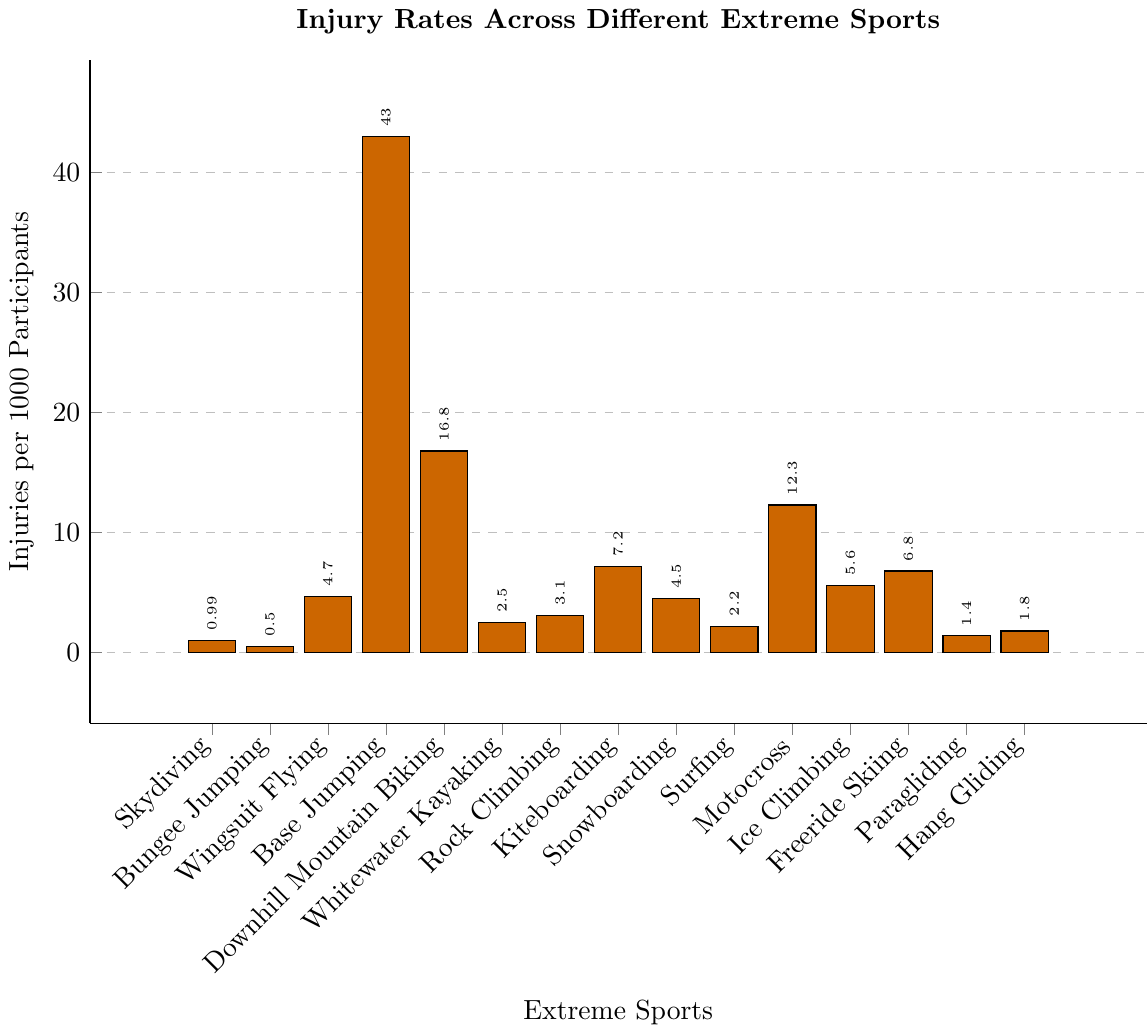Which sport has the highest injury rate? The sport with the highest injury rate can be identified by looking for the tallest bar in the bar chart. Base Jumping has the tallest bar.
Answer: Base Jumping Which two sports have the lowest injury rates? The two sports with the shortest bars represent the lowest injury rates. The shortest bars belong to Bungee Jumping and Skydiving.
Answer: Bungee Jumping and Skydiving What is the difference in injury rates between Motocross and Snowboarding? To find the difference, subtract the injury rate of Snowboarding (4.5) from the injury rate of Motocross (12.3). 12.3 - 4.5 = 7.8.
Answer: 7.8 Which sport has an injury rate closest to 5 injuries per 1000 participants? By examining the heights of the bars near the 5 mark on the y-axis, we see that Ice Climbing (5.6) is the closest.
Answer: Ice Climbing How do the injury rates of Hang Gliding and Paragliding compare? Compare the heights of the bars for Hang Gliding (1.8) and Paragliding (1.4). Hang Gliding has a slightly higher injury rate than Paragliding.
Answer: Hang Gliding has a higher rate What is the average injury rate across all listed extreme sports? Add all the injury rates and divide by the number of sports. Total injuries = 0.99+0.5+4.7+43+16.8+2.5+3.1+7.2+4.5+2.2+12.3+5.6+6.8+1.4+1.8 = 113.19. Number of sports = 15. Average = 113.19 / 15 = 7.55.
Answer: 7.55 By how much does the injury rate of Downhill Mountain Biking exceed that of Surfing? To find the excess, subtract the injury rate of Surfing (2.2) from Downhill Mountain Biking (16.8). 16.8 - 2.2 = 14.6.
Answer: 14.6 Which sports have an injury rate greater than 5 but less than 10? Identify the bars that fall in the range greater than 5 and less than 10. These are Ice Climbing (5.6), Kiteboarding (7.2), and Freeride Skiing (6.8).
Answer: Ice Climbing, Kiteboarding, and Freeride Skiing 